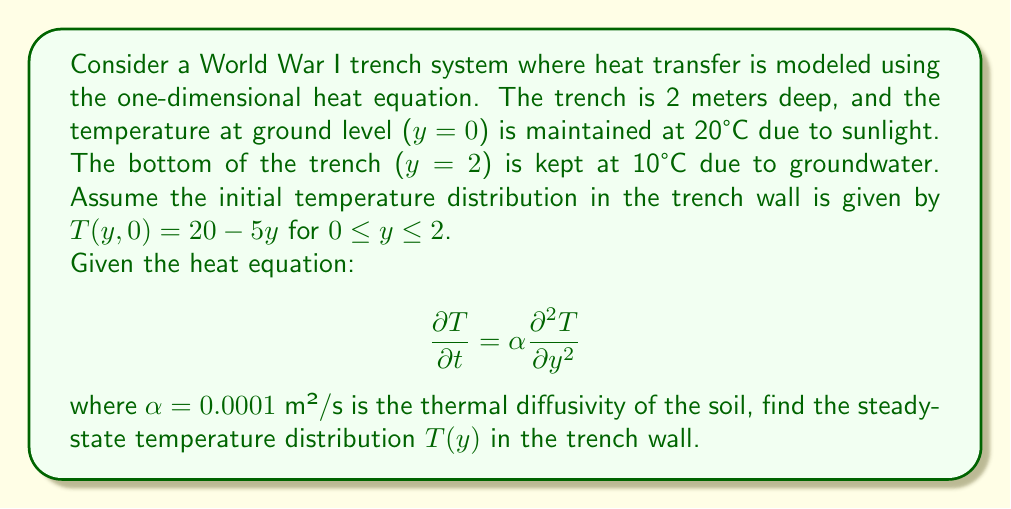Teach me how to tackle this problem. To solve this problem, we need to follow these steps:

1) For the steady-state solution, the temperature doesn't change with time, so $\frac{\partial T}{\partial t} = 0$. This reduces our heat equation to:

   $$ 0 = \alpha \frac{d^2 T}{dy^2} $$

2) Simplifying, we get:

   $$ \frac{d^2 T}{dy^2} = 0 $$

3) Integrating twice:

   $$ \frac{dT}{dy} = C_1 $$
   $$ T(y) = C_1y + C_2 $$

   where $C_1$ and $C_2$ are constants to be determined from the boundary conditions.

4) We have two boundary conditions:
   - At y = 0, T = 20°C
   - At y = 2, T = 10°C

5) Applying these conditions:

   At y = 0: $20 = C_2$
   At y = 2: $10 = 2C_1 + C_2 = 2C_1 + 20$

6) From the second equation:
   $10 = 2C_1 + 20$
   $-10 = 2C_1$
   $C_1 = -5$

7) Therefore, the steady-state temperature distribution is:

   $$ T(y) = -5y + 20 $$

This linear distribution shows that the temperature decreases steadily from 20°C at the surface to 10°C at the bottom of the trench.
Answer: $$ T(y) = -5y + 20 $$
where y is the depth in meters and T is the temperature in °C. 